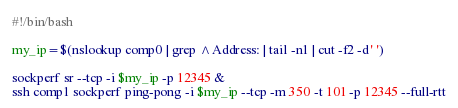Convert code to text. <code><loc_0><loc_0><loc_500><loc_500><_Bash_>#!/bin/bash

my_ip=$(nslookup comp0 | grep ^Address: | tail -n1 | cut -f2 -d' ')

sockperf sr --tcp -i $my_ip -p 12345 &
ssh comp1 sockperf ping-pong -i $my_ip --tcp -m 350 -t 101 -p 12345 --full-rtt</code> 